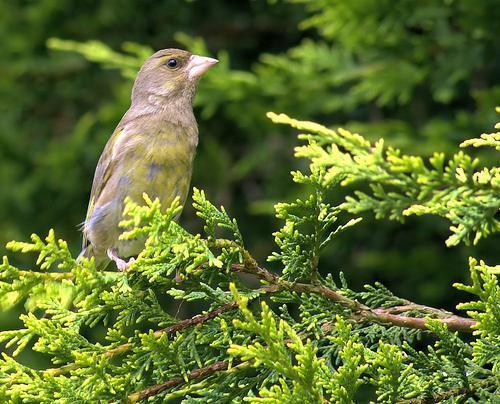How many birds are in the picture?
Give a very brief answer. 1. 